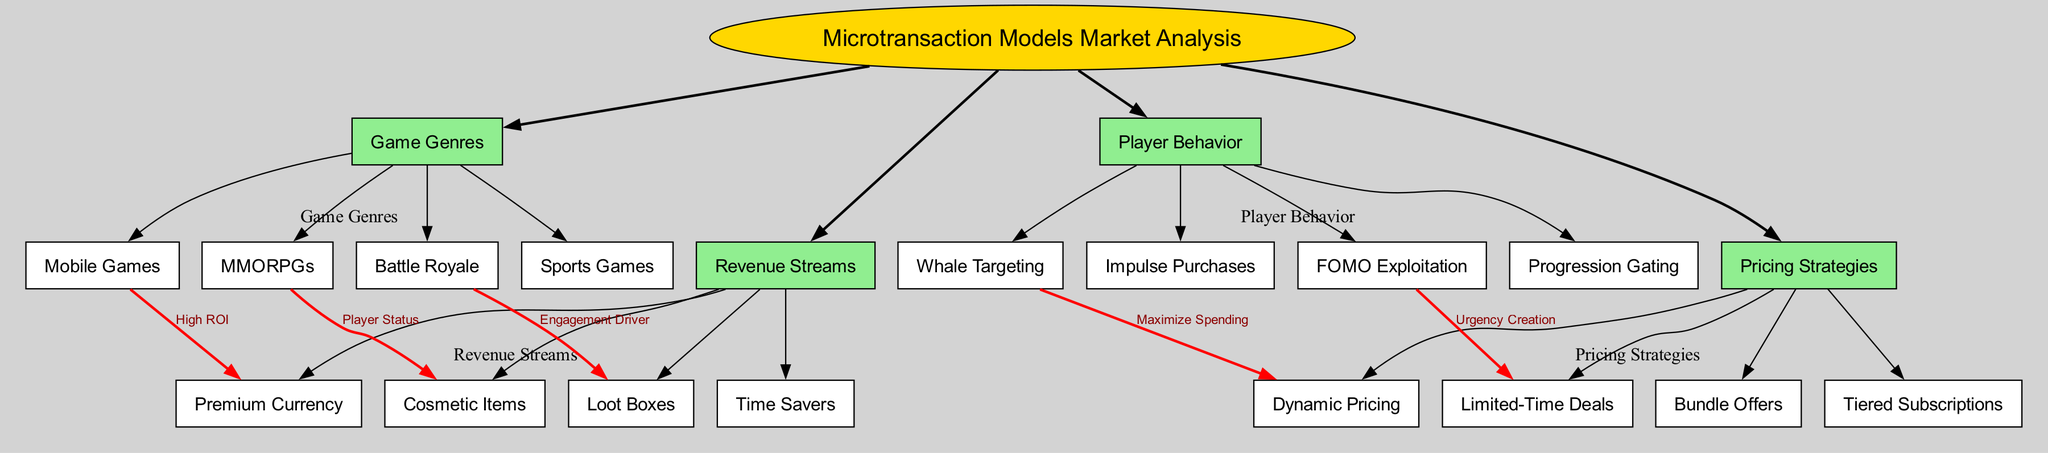What are the four main categories in the diagram? The diagram contains four main categories: Game Genres, Revenue Streams, Player Behavior, and Pricing Strategies. These categories are directly linked to the central concept, allowing for easy identification.
Answer: Game Genres, Revenue Streams, Player Behavior, Pricing Strategies Which game genre is associated with Premium Currency? The connection in the diagram indicates that Mobile Games are linked to Premium Currency with a label stating "High ROI". This establishes that Mobile Games generate significant returns from this type of microtransaction.
Answer: Mobile Games What is the label connecting MMORPGs to Cosmetic Items? The relationship between MMORPGs and Cosmetic Items is labeled as "Player Status", indicating that cosmetic items in MMORPGs are often used to display player prestige or achievements.
Answer: Player Status How many player behavior subcategories are listed in the diagram? The diagram shows that there are four subcategories under Player Behavior: Whale Targeting, Impulse Purchases, FOMO Exploitation, and Progression Gating. Counting these gives a total of four.
Answer: Four Which connection indicates that Loot Boxes are an engagement driver for a specific game genre? The diagram establishes a connection between Battle Royale and Loot Boxes, labeled as "Engagement Driver", indicating that Loot Boxes are used to enhance player engagement in Battle Royale games.
Answer: Battle Royale Which player behavior is linked to Dynamic Pricing? The connection shows Whale Targeting as the behavior linked to Dynamic Pricing, suggesting a strategy that aims to maximize spending from high-value players (whales) through varied pricing.
Answer: Whale Targeting How does FOMO Exploitation relate to specific pricing strategies? The diagram connects FOMO Exploitation to Limited-Time Deals, indicating that the fear of missing out is leveraged to create urgency for players to make purchases during special offers.
Answer: Limited-Time Deals What type of pricing strategy might utilize Bundle Offers? While the diagram does not directly link Bundle Offers to a specific game genre, it implies that pricing strategies aim to optimize revenues, suggesting Bundle Offers might be used broadly across any genre to enhance sales.
Answer: Not specified What is the purpose of the connections between nodes in this diagram? The connections illustrate relationships and influences among various concepts. Each connection provides insight into how different categories interact and affect each other, indicating their roles in maximizing revenue from microtransactions.
Answer: Relationships and influences 